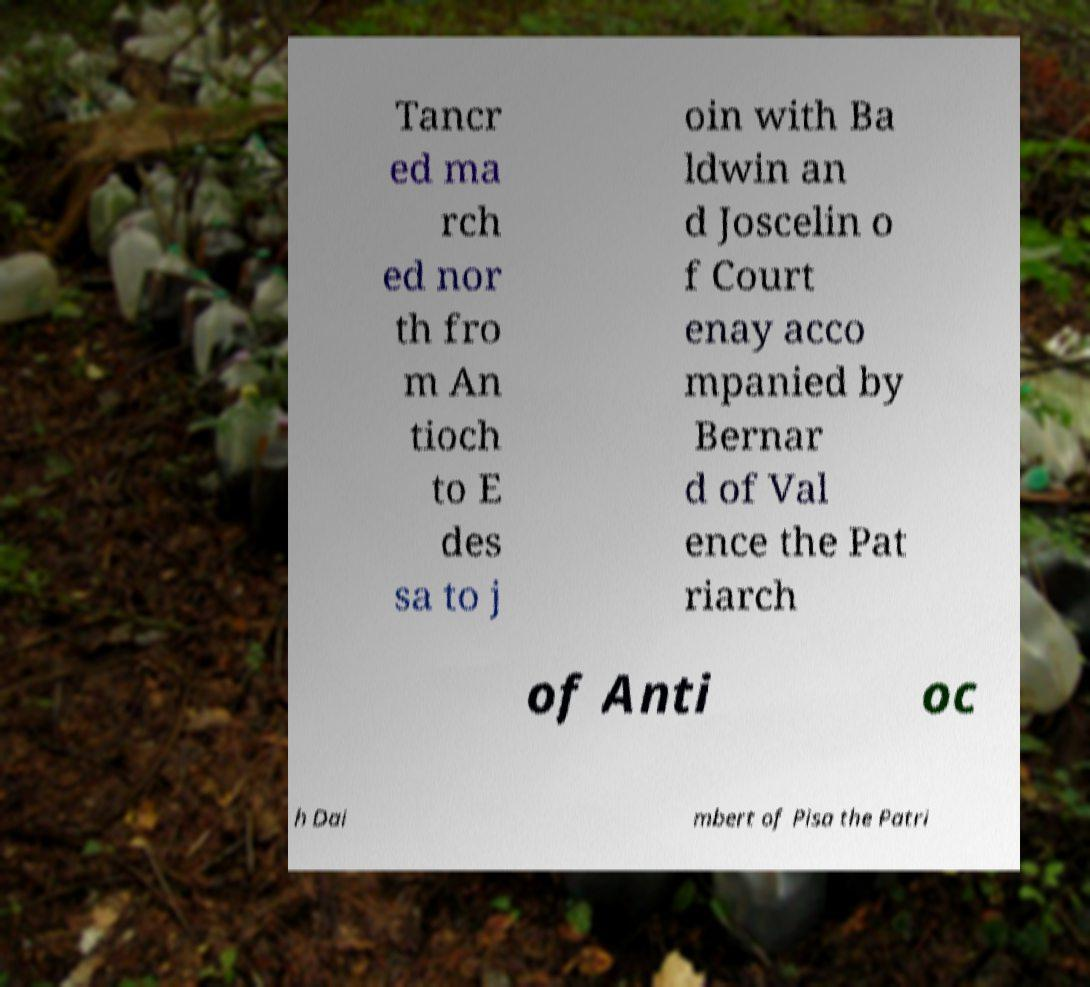Please read and relay the text visible in this image. What does it say? Tancr ed ma rch ed nor th fro m An tioch to E des sa to j oin with Ba ldwin an d Joscelin o f Court enay acco mpanied by Bernar d of Val ence the Pat riarch of Anti oc h Dai mbert of Pisa the Patri 